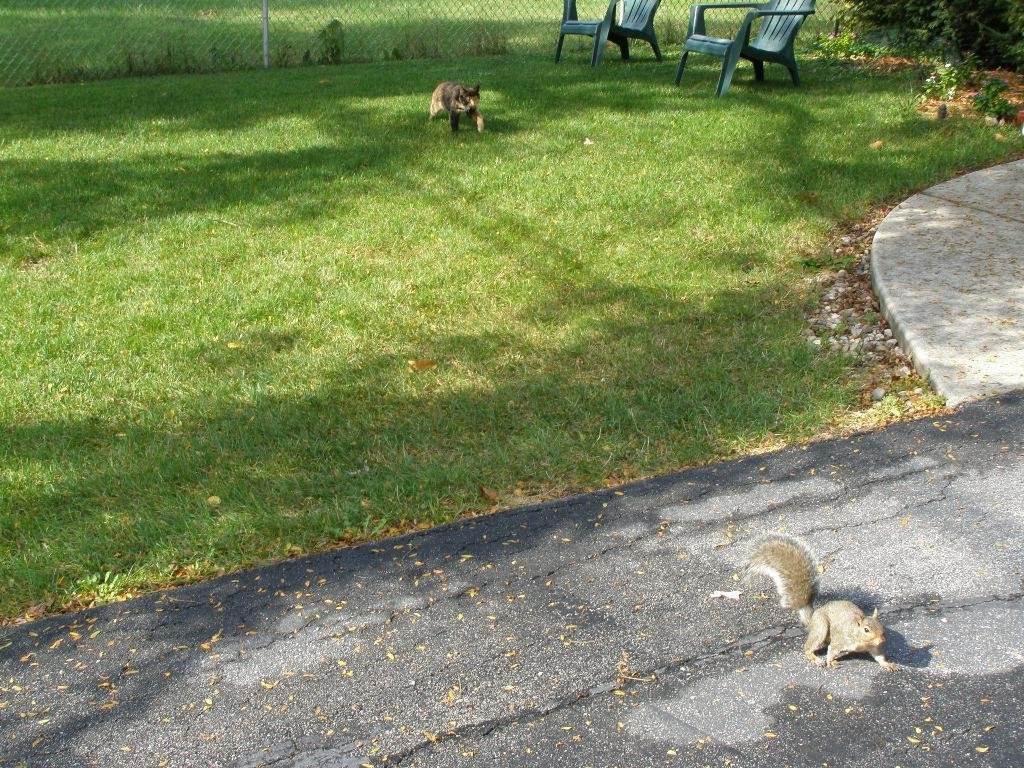What animal is present in the center of the image? There is a squirrel in the center of the image. What type of vegetation can be seen in the image? There is grass visible in the image. How many chairs are in the image? There are two chairs in the image. What can be seen in the background of the image? There is fencing in the background of the image. Can you describe the root system of the squirrel in the image? There is no root system associated with the squirrel in the image, as it is a mammal and not a plant. 